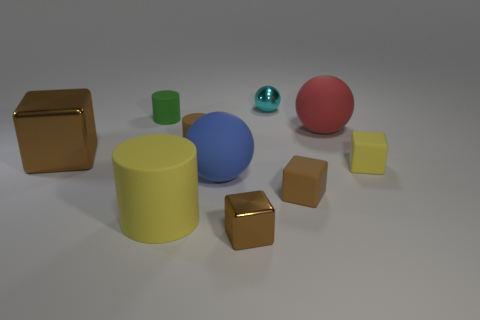What size is the metallic cube that is left of the large blue sphere?
Provide a succinct answer. Large. Is the material of the large yellow object the same as the red object?
Offer a very short reply. Yes. The big blue thing that is the same material as the large red object is what shape?
Your answer should be compact. Sphere. Is there anything else of the same color as the big cylinder?
Offer a terse response. Yes. There is a metal thing in front of the yellow rubber cylinder; what color is it?
Your answer should be compact. Brown. There is a matte ball that is in front of the small yellow thing; does it have the same color as the large metal cube?
Ensure brevity in your answer.  No. There is a blue thing that is the same shape as the cyan shiny thing; what is it made of?
Give a very brief answer. Rubber. What number of rubber cubes are the same size as the cyan object?
Provide a succinct answer. 2. The tiny brown metallic thing has what shape?
Provide a succinct answer. Cube. There is a ball that is in front of the small green rubber object and on the right side of the large blue ball; what is its size?
Keep it short and to the point. Large. 